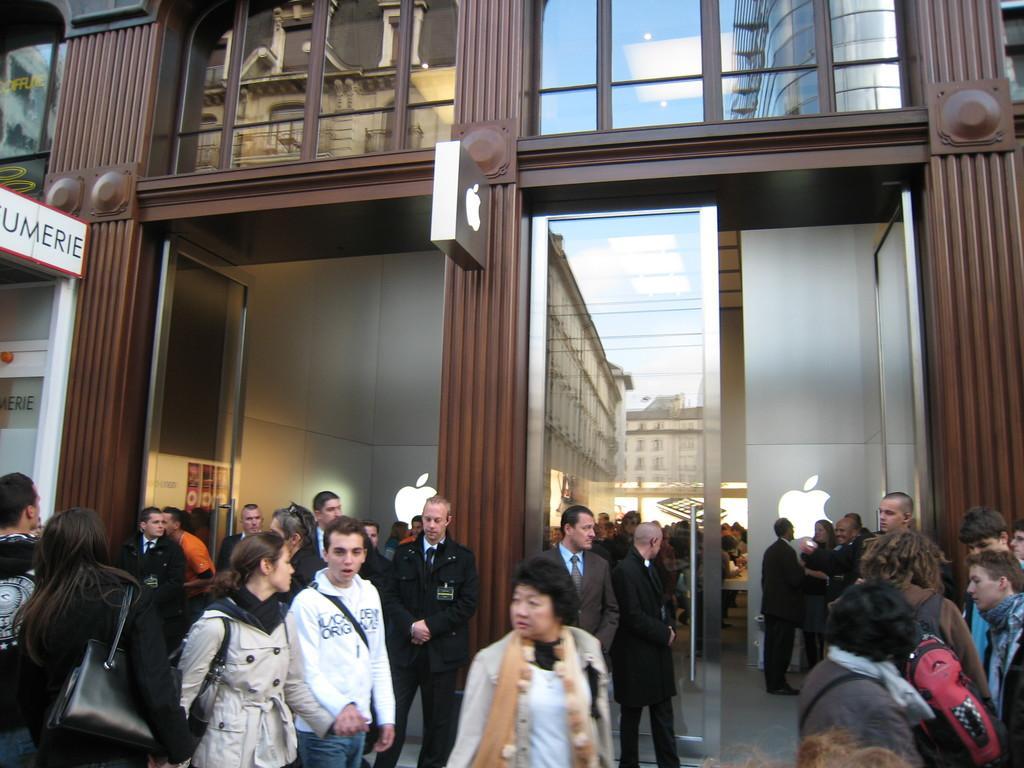Could you give a brief overview of what you see in this image? In the foreground of the image there are many people standing and walking. At the background of the image there is a building. There is a door. 